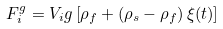<formula> <loc_0><loc_0><loc_500><loc_500>F _ { i } ^ { g } = V _ { i } g \left [ \rho _ { f } + \left ( \rho _ { s } - \rho _ { f } \right ) \xi ( t ) \right ]</formula> 